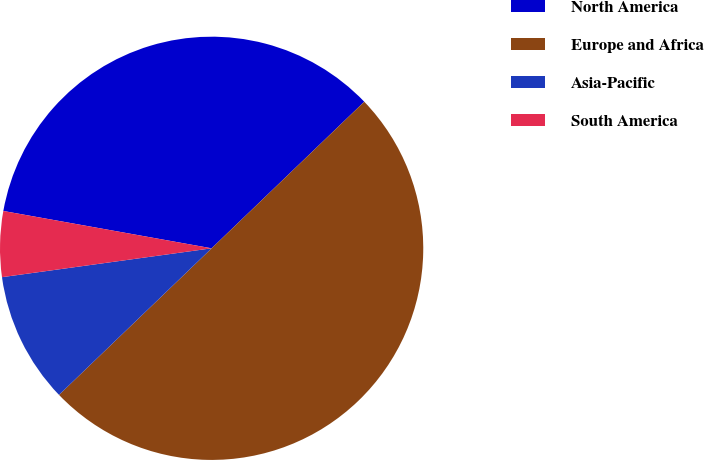Convert chart to OTSL. <chart><loc_0><loc_0><loc_500><loc_500><pie_chart><fcel>North America<fcel>Europe and Africa<fcel>Asia-Pacific<fcel>South America<nl><fcel>35.0%<fcel>50.0%<fcel>10.0%<fcel>5.0%<nl></chart> 